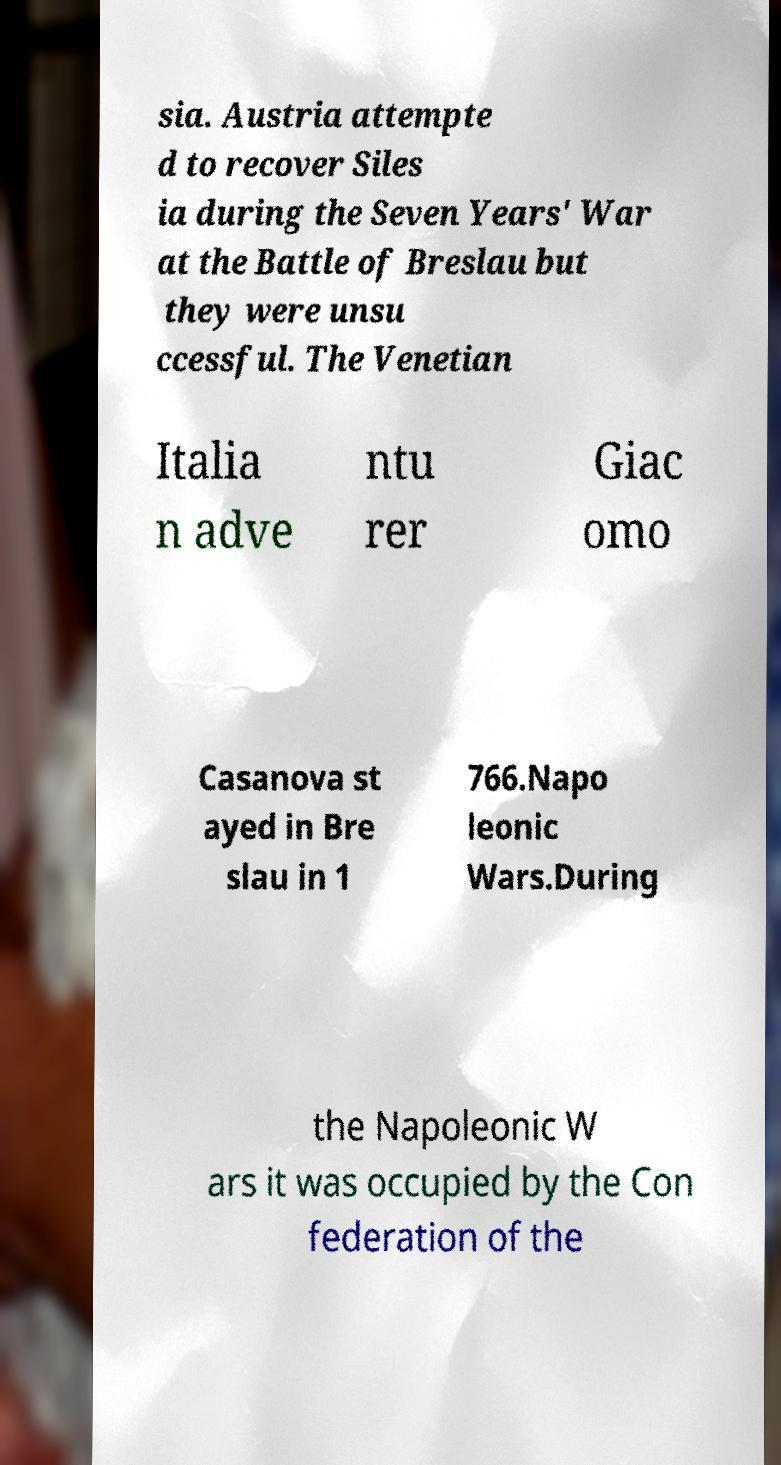I need the written content from this picture converted into text. Can you do that? sia. Austria attempte d to recover Siles ia during the Seven Years' War at the Battle of Breslau but they were unsu ccessful. The Venetian Italia n adve ntu rer Giac omo Casanova st ayed in Bre slau in 1 766.Napo leonic Wars.During the Napoleonic W ars it was occupied by the Con federation of the 